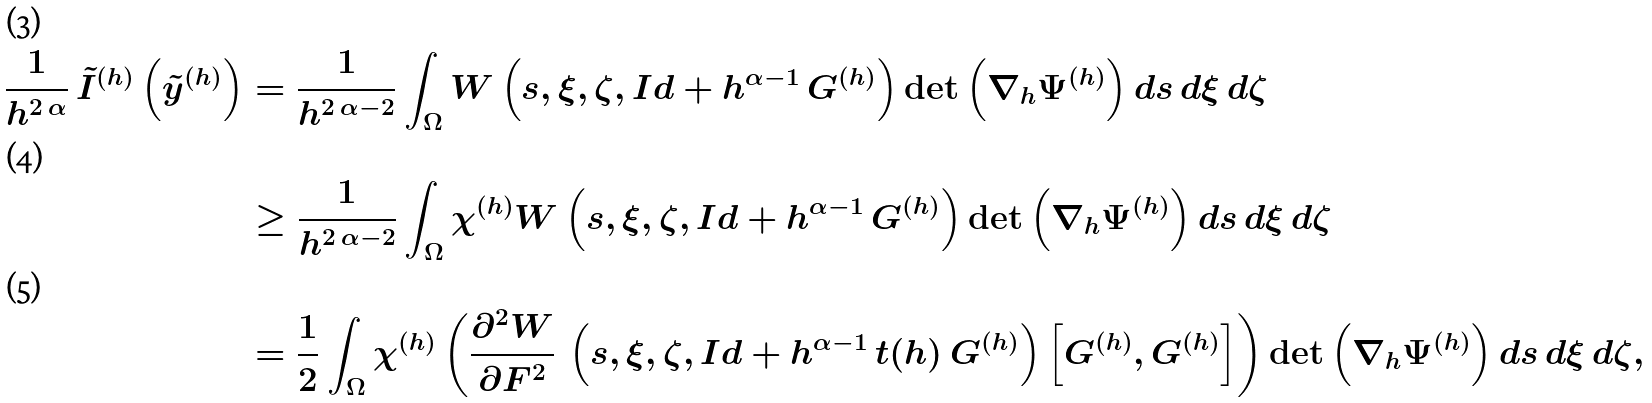Convert formula to latex. <formula><loc_0><loc_0><loc_500><loc_500>\frac { 1 } { h ^ { 2 \, \alpha } } \, \tilde { I } ^ { ( h ) } \left ( \tilde { y } ^ { ( h ) } \right ) & = \frac { 1 } { h ^ { 2 \, \alpha - 2 } } \int _ { \Omega } W \left ( s , \xi , \zeta , I d + h ^ { \alpha - 1 } \, G ^ { ( h ) } \right ) \det \left ( \nabla _ { h } \Psi ^ { ( h ) } \right ) d s \, d \xi \, d \zeta \\ & \geq \frac { 1 } { h ^ { 2 \, \alpha - 2 } } \int _ { \Omega } \chi ^ { ( h ) } W \left ( s , \xi , \zeta , I d + h ^ { \alpha - 1 } \, G ^ { ( h ) } \right ) \det \left ( \nabla _ { h } \Psi ^ { ( h ) } \right ) d s \, d \xi \, d \zeta \\ & = \frac { 1 } { 2 } \int _ { \Omega } \chi ^ { ( h ) } \left ( \frac { \partial ^ { 2 } W } { \partial F ^ { 2 } } \, \left ( s , \xi , \zeta , I d + h ^ { \alpha - 1 } \, t ( h ) \, G ^ { ( h ) } \right ) \left [ G ^ { ( h ) } , G ^ { ( h ) } \right ] \right ) \det \left ( \nabla _ { h } \Psi ^ { ( h ) } \right ) d s \, d \xi \, d \zeta ,</formula> 